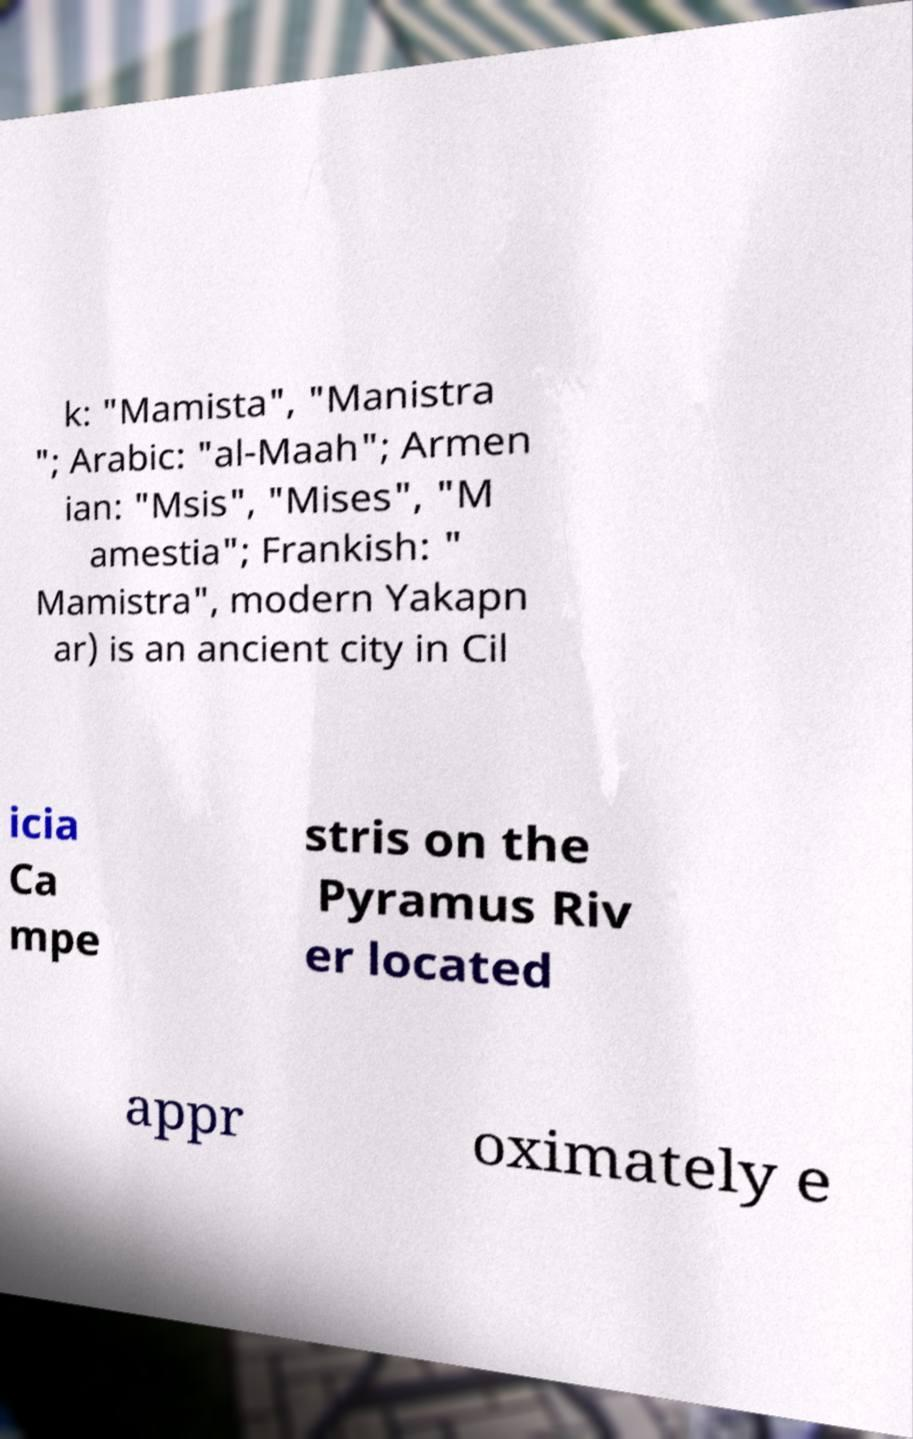For documentation purposes, I need the text within this image transcribed. Could you provide that? k: "Mamista", "Manistra "; Arabic: "al-Maah"; Armen ian: "Msis", "Mises", "M amestia"; Frankish: " Mamistra", modern Yakapn ar) is an ancient city in Cil icia Ca mpe stris on the Pyramus Riv er located appr oximately e 